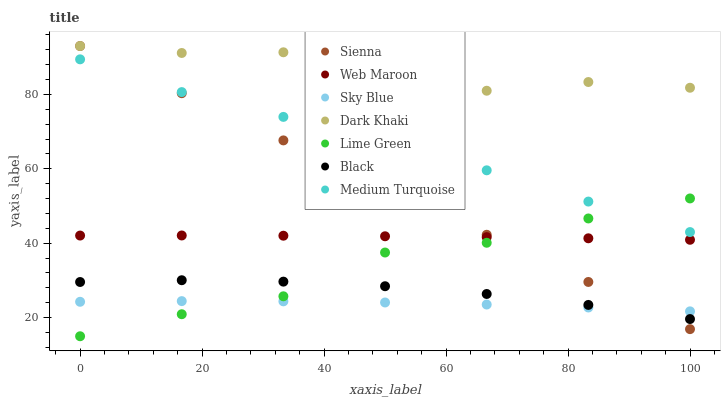Does Sky Blue have the minimum area under the curve?
Answer yes or no. Yes. Does Dark Khaki have the maximum area under the curve?
Answer yes or no. Yes. Does Web Maroon have the minimum area under the curve?
Answer yes or no. No. Does Web Maroon have the maximum area under the curve?
Answer yes or no. No. Is Sienna the smoothest?
Answer yes or no. Yes. Is Dark Khaki the roughest?
Answer yes or no. Yes. Is Web Maroon the smoothest?
Answer yes or no. No. Is Web Maroon the roughest?
Answer yes or no. No. Does Lime Green have the lowest value?
Answer yes or no. Yes. Does Web Maroon have the lowest value?
Answer yes or no. No. Does Sienna have the highest value?
Answer yes or no. Yes. Does Web Maroon have the highest value?
Answer yes or no. No. Is Medium Turquoise less than Dark Khaki?
Answer yes or no. Yes. Is Web Maroon greater than Black?
Answer yes or no. Yes. Does Sky Blue intersect Sienna?
Answer yes or no. Yes. Is Sky Blue less than Sienna?
Answer yes or no. No. Is Sky Blue greater than Sienna?
Answer yes or no. No. Does Medium Turquoise intersect Dark Khaki?
Answer yes or no. No. 